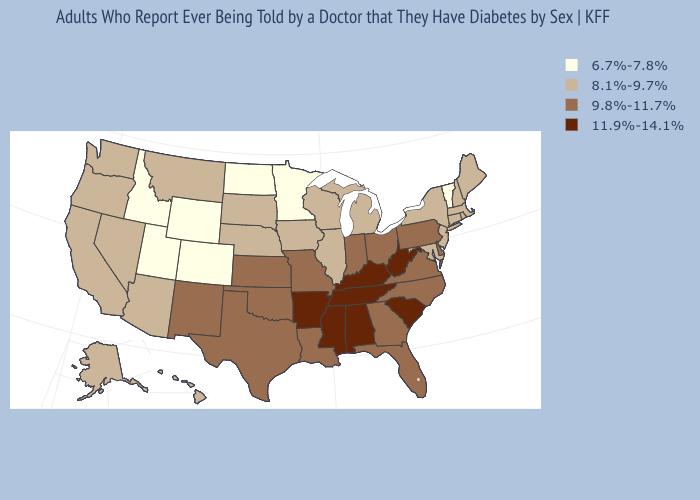Which states hav the highest value in the West?
Give a very brief answer. New Mexico. Does California have a lower value than Idaho?
Keep it brief. No. Among the states that border Michigan , does Ohio have the highest value?
Concise answer only. Yes. What is the value of Ohio?
Give a very brief answer. 9.8%-11.7%. What is the highest value in the USA?
Concise answer only. 11.9%-14.1%. Name the states that have a value in the range 8.1%-9.7%?
Short answer required. Alaska, Arizona, California, Connecticut, Hawaii, Illinois, Iowa, Maine, Maryland, Massachusetts, Michigan, Montana, Nebraska, Nevada, New Hampshire, New Jersey, New York, Oregon, Rhode Island, South Dakota, Washington, Wisconsin. Which states have the highest value in the USA?
Write a very short answer. Alabama, Arkansas, Kentucky, Mississippi, South Carolina, Tennessee, West Virginia. Does South Carolina have a lower value than Mississippi?
Concise answer only. No. Which states have the highest value in the USA?
Concise answer only. Alabama, Arkansas, Kentucky, Mississippi, South Carolina, Tennessee, West Virginia. Which states have the lowest value in the West?
Answer briefly. Colorado, Idaho, Utah, Wyoming. Name the states that have a value in the range 9.8%-11.7%?
Answer briefly. Delaware, Florida, Georgia, Indiana, Kansas, Louisiana, Missouri, New Mexico, North Carolina, Ohio, Oklahoma, Pennsylvania, Texas, Virginia. What is the value of Connecticut?
Write a very short answer. 8.1%-9.7%. What is the highest value in states that border North Dakota?
Keep it brief. 8.1%-9.7%. Among the states that border Delaware , does Pennsylvania have the lowest value?
Keep it brief. No. Name the states that have a value in the range 9.8%-11.7%?
Answer briefly. Delaware, Florida, Georgia, Indiana, Kansas, Louisiana, Missouri, New Mexico, North Carolina, Ohio, Oklahoma, Pennsylvania, Texas, Virginia. 